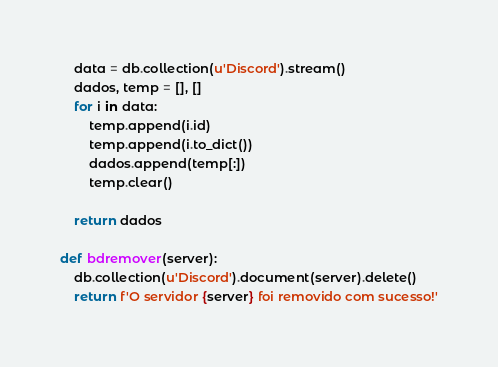<code> <loc_0><loc_0><loc_500><loc_500><_Python_>    data = db.collection(u'Discord').stream()
    dados, temp = [], []
    for i in data:
        temp.append(i.id)
        temp.append(i.to_dict())
        dados.append(temp[:])
        temp.clear()

    return dados

def bdremover(server):
    db.collection(u'Discord').document(server).delete()
    return f'O servidor {server} foi removido com sucesso!'</code> 